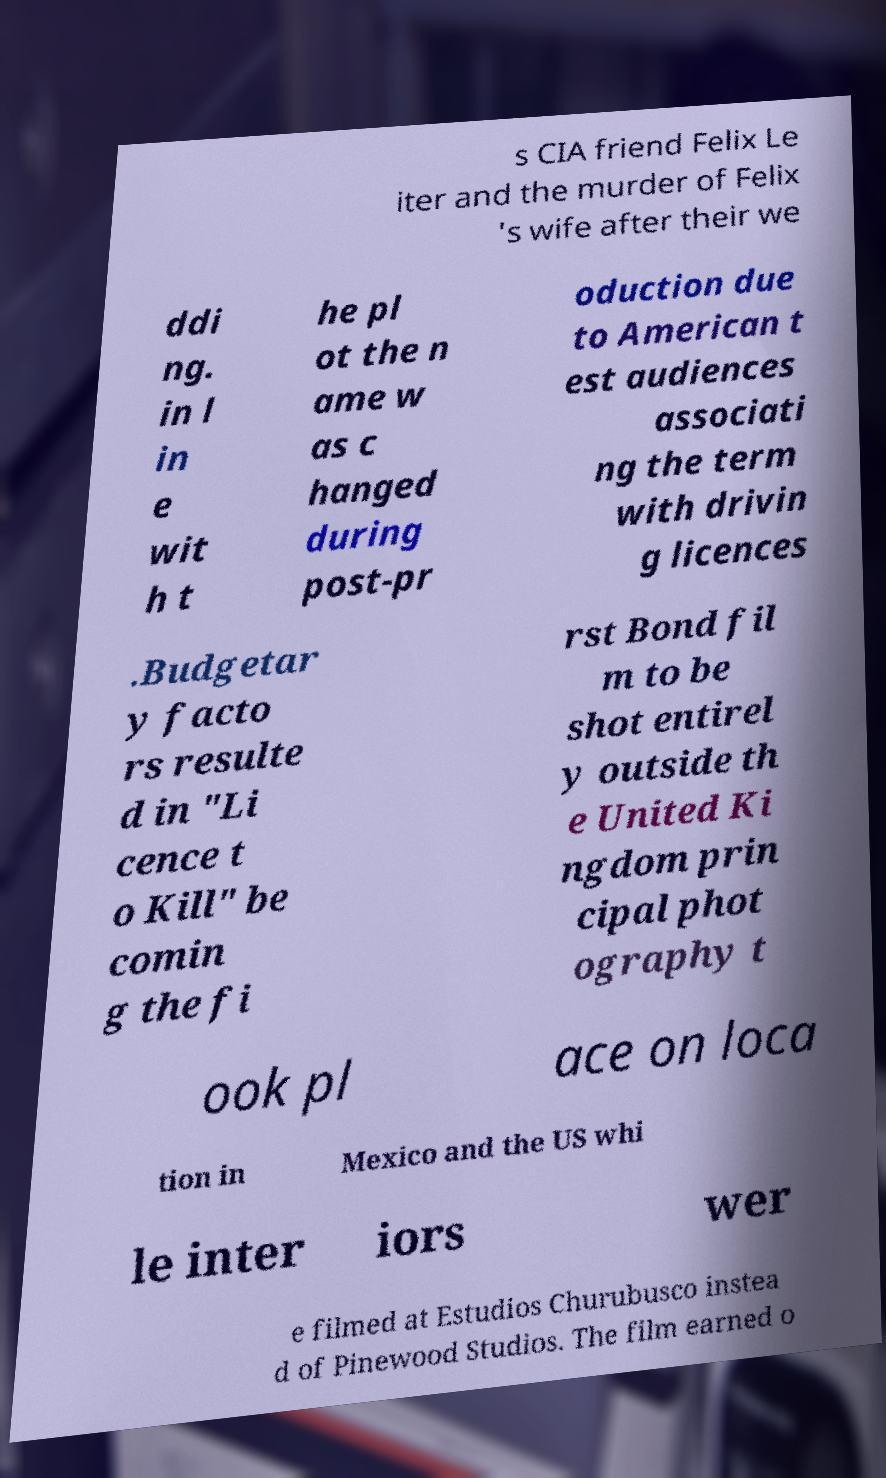Please read and relay the text visible in this image. What does it say? s CIA friend Felix Le iter and the murder of Felix 's wife after their we ddi ng. in l in e wit h t he pl ot the n ame w as c hanged during post-pr oduction due to American t est audiences associati ng the term with drivin g licences .Budgetar y facto rs resulte d in "Li cence t o Kill" be comin g the fi rst Bond fil m to be shot entirel y outside th e United Ki ngdom prin cipal phot ography t ook pl ace on loca tion in Mexico and the US whi le inter iors wer e filmed at Estudios Churubusco instea d of Pinewood Studios. The film earned o 